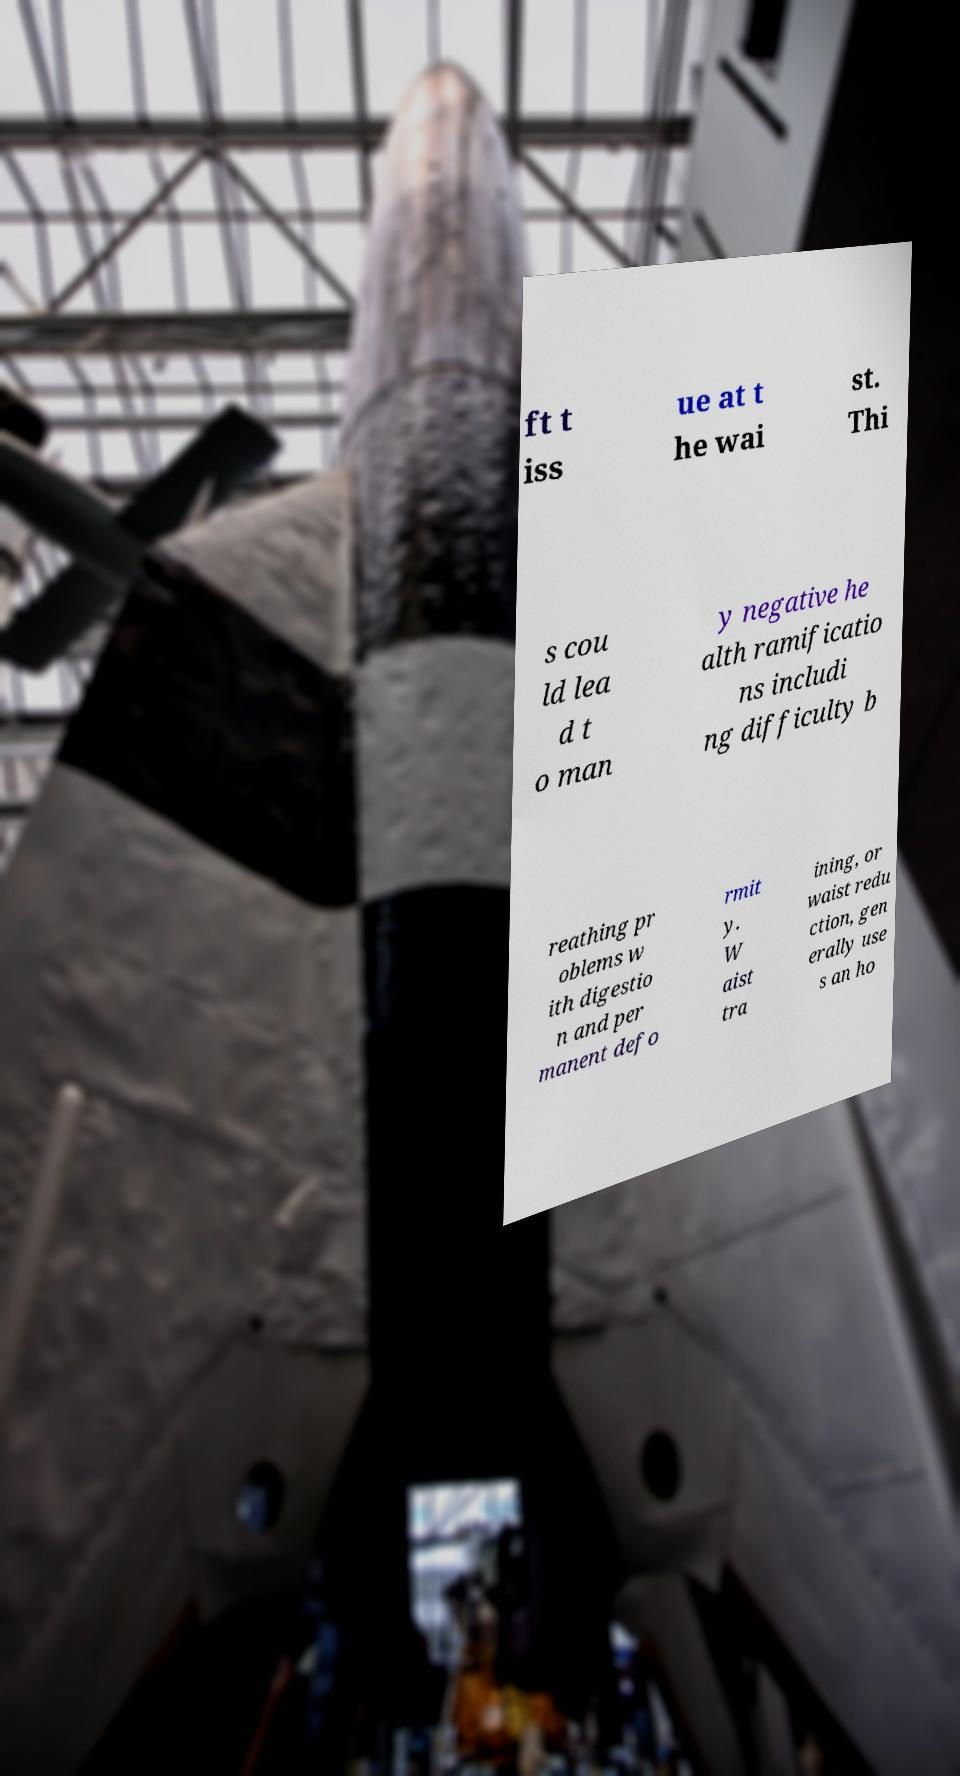For documentation purposes, I need the text within this image transcribed. Could you provide that? ft t iss ue at t he wai st. Thi s cou ld lea d t o man y negative he alth ramificatio ns includi ng difficulty b reathing pr oblems w ith digestio n and per manent defo rmit y. W aist tra ining, or waist redu ction, gen erally use s an ho 